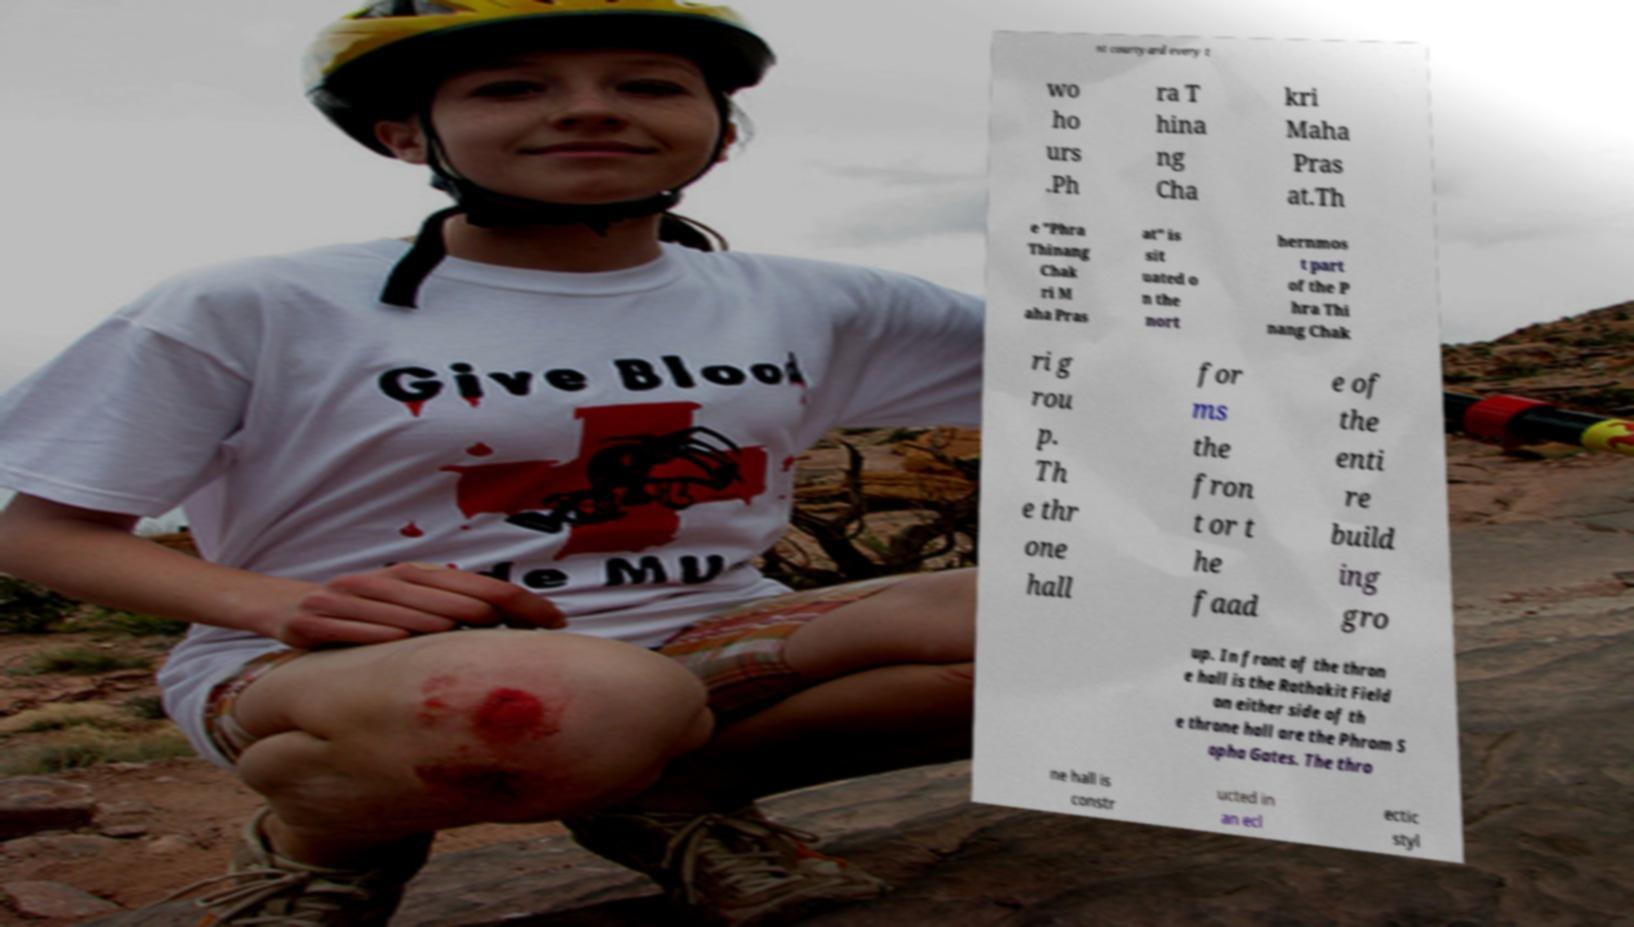What messages or text are displayed in this image? I need them in a readable, typed format. nt courtyard every t wo ho urs .Ph ra T hina ng Cha kri Maha Pras at.Th e "Phra Thinang Chak ri M aha Pras at" is sit uated o n the nort hernmos t part of the P hra Thi nang Chak ri g rou p. Th e thr one hall for ms the fron t or t he faad e of the enti re build ing gro up. In front of the thron e hall is the Rathakit Field on either side of th e throne hall are the Phrom S opha Gates. The thro ne hall is constr ucted in an ecl ectic styl 